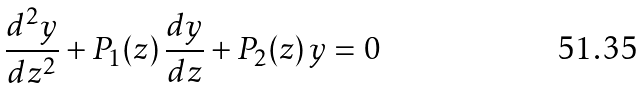Convert formula to latex. <formula><loc_0><loc_0><loc_500><loc_500>\frac { d ^ { 2 } y } { d z ^ { 2 } } + P _ { 1 } ( z ) \, \frac { d y } { d z } + P _ { 2 } ( z ) \, y = 0</formula> 